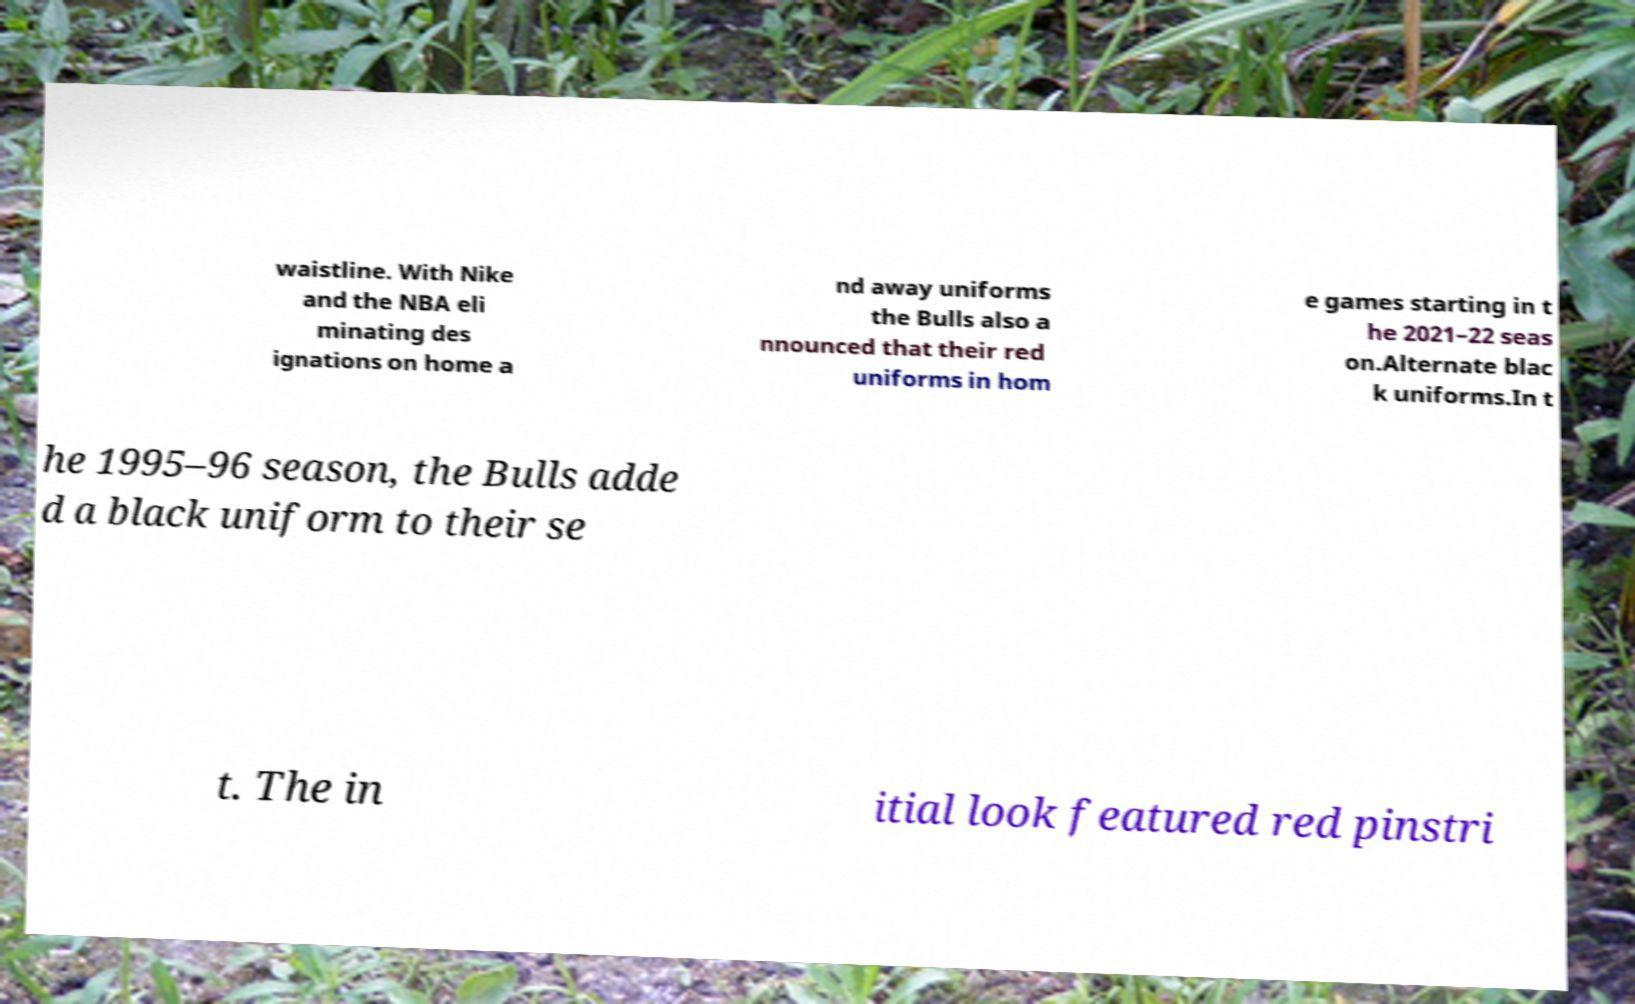Can you accurately transcribe the text from the provided image for me? waistline. With Nike and the NBA eli minating des ignations on home a nd away uniforms the Bulls also a nnounced that their red uniforms in hom e games starting in t he 2021–22 seas on.Alternate blac k uniforms.In t he 1995–96 season, the Bulls adde d a black uniform to their se t. The in itial look featured red pinstri 